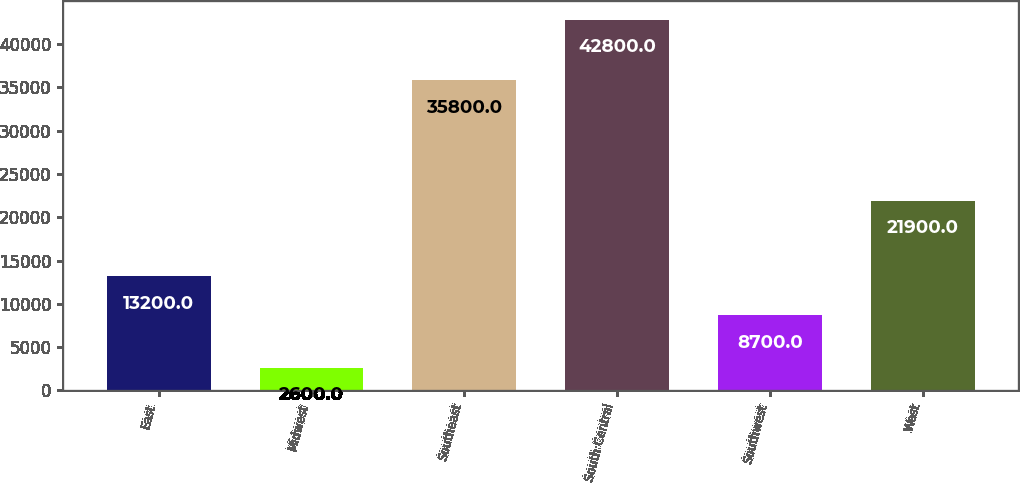<chart> <loc_0><loc_0><loc_500><loc_500><bar_chart><fcel>East<fcel>Midwest<fcel>Southeast<fcel>South Central<fcel>Southwest<fcel>West<nl><fcel>13200<fcel>2600<fcel>35800<fcel>42800<fcel>8700<fcel>21900<nl></chart> 